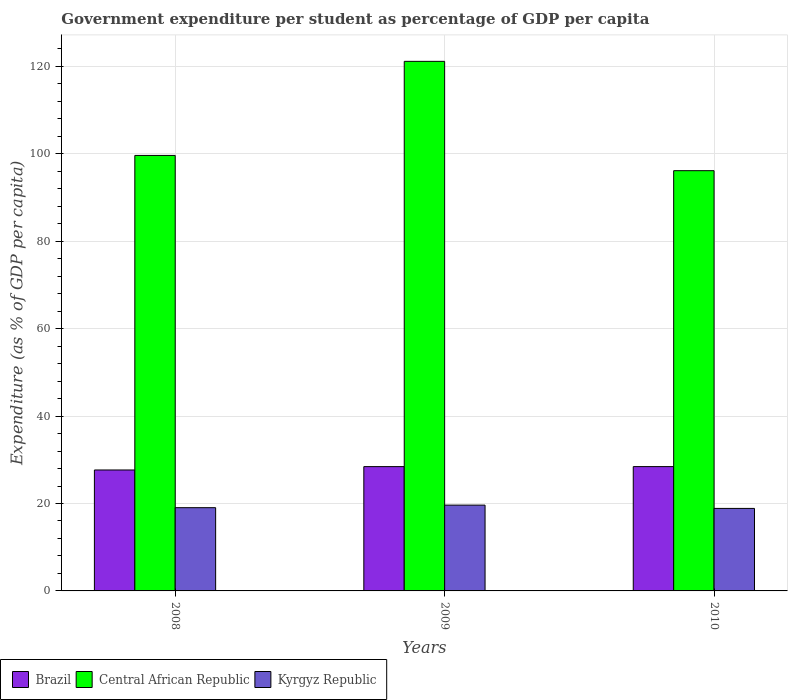How many different coloured bars are there?
Provide a short and direct response. 3. How many bars are there on the 1st tick from the right?
Your answer should be very brief. 3. What is the label of the 2nd group of bars from the left?
Give a very brief answer. 2009. In how many cases, is the number of bars for a given year not equal to the number of legend labels?
Your response must be concise. 0. What is the percentage of expenditure per student in Kyrgyz Republic in 2008?
Ensure brevity in your answer.  19.04. Across all years, what is the maximum percentage of expenditure per student in Central African Republic?
Provide a short and direct response. 121.16. Across all years, what is the minimum percentage of expenditure per student in Kyrgyz Republic?
Provide a short and direct response. 18.88. In which year was the percentage of expenditure per student in Brazil minimum?
Make the answer very short. 2008. What is the total percentage of expenditure per student in Kyrgyz Republic in the graph?
Ensure brevity in your answer.  57.55. What is the difference between the percentage of expenditure per student in Central African Republic in 2008 and that in 2010?
Keep it short and to the point. 3.49. What is the difference between the percentage of expenditure per student in Kyrgyz Republic in 2008 and the percentage of expenditure per student in Brazil in 2009?
Your answer should be compact. -9.4. What is the average percentage of expenditure per student in Central African Republic per year?
Make the answer very short. 105.64. In the year 2010, what is the difference between the percentage of expenditure per student in Kyrgyz Republic and percentage of expenditure per student in Central African Republic?
Provide a succinct answer. -77.27. What is the ratio of the percentage of expenditure per student in Brazil in 2009 to that in 2010?
Ensure brevity in your answer.  1. What is the difference between the highest and the second highest percentage of expenditure per student in Kyrgyz Republic?
Your answer should be very brief. 0.59. What is the difference between the highest and the lowest percentage of expenditure per student in Kyrgyz Republic?
Provide a succinct answer. 0.75. In how many years, is the percentage of expenditure per student in Central African Republic greater than the average percentage of expenditure per student in Central African Republic taken over all years?
Offer a very short reply. 1. What does the 3rd bar from the left in 2008 represents?
Make the answer very short. Kyrgyz Republic. What does the 2nd bar from the right in 2010 represents?
Ensure brevity in your answer.  Central African Republic. How many bars are there?
Provide a short and direct response. 9. How many years are there in the graph?
Offer a terse response. 3. Does the graph contain any zero values?
Ensure brevity in your answer.  No. How many legend labels are there?
Provide a succinct answer. 3. How are the legend labels stacked?
Offer a terse response. Horizontal. What is the title of the graph?
Your answer should be very brief. Government expenditure per student as percentage of GDP per capita. What is the label or title of the X-axis?
Your answer should be compact. Years. What is the label or title of the Y-axis?
Your answer should be very brief. Expenditure (as % of GDP per capita). What is the Expenditure (as % of GDP per capita) of Brazil in 2008?
Offer a terse response. 27.67. What is the Expenditure (as % of GDP per capita) in Central African Republic in 2008?
Offer a very short reply. 99.63. What is the Expenditure (as % of GDP per capita) of Kyrgyz Republic in 2008?
Offer a terse response. 19.04. What is the Expenditure (as % of GDP per capita) in Brazil in 2009?
Your answer should be very brief. 28.44. What is the Expenditure (as % of GDP per capita) of Central African Republic in 2009?
Provide a short and direct response. 121.16. What is the Expenditure (as % of GDP per capita) of Kyrgyz Republic in 2009?
Ensure brevity in your answer.  19.63. What is the Expenditure (as % of GDP per capita) in Brazil in 2010?
Offer a terse response. 28.44. What is the Expenditure (as % of GDP per capita) in Central African Republic in 2010?
Provide a short and direct response. 96.14. What is the Expenditure (as % of GDP per capita) in Kyrgyz Republic in 2010?
Make the answer very short. 18.88. Across all years, what is the maximum Expenditure (as % of GDP per capita) in Brazil?
Offer a very short reply. 28.44. Across all years, what is the maximum Expenditure (as % of GDP per capita) of Central African Republic?
Your answer should be very brief. 121.16. Across all years, what is the maximum Expenditure (as % of GDP per capita) in Kyrgyz Republic?
Offer a very short reply. 19.63. Across all years, what is the minimum Expenditure (as % of GDP per capita) in Brazil?
Offer a terse response. 27.67. Across all years, what is the minimum Expenditure (as % of GDP per capita) of Central African Republic?
Provide a short and direct response. 96.14. Across all years, what is the minimum Expenditure (as % of GDP per capita) in Kyrgyz Republic?
Keep it short and to the point. 18.88. What is the total Expenditure (as % of GDP per capita) in Brazil in the graph?
Provide a succinct answer. 84.55. What is the total Expenditure (as % of GDP per capita) of Central African Republic in the graph?
Your answer should be compact. 316.93. What is the total Expenditure (as % of GDP per capita) in Kyrgyz Republic in the graph?
Make the answer very short. 57.55. What is the difference between the Expenditure (as % of GDP per capita) of Brazil in 2008 and that in 2009?
Make the answer very short. -0.77. What is the difference between the Expenditure (as % of GDP per capita) of Central African Republic in 2008 and that in 2009?
Your answer should be compact. -21.52. What is the difference between the Expenditure (as % of GDP per capita) in Kyrgyz Republic in 2008 and that in 2009?
Provide a short and direct response. -0.59. What is the difference between the Expenditure (as % of GDP per capita) of Brazil in 2008 and that in 2010?
Offer a terse response. -0.77. What is the difference between the Expenditure (as % of GDP per capita) in Central African Republic in 2008 and that in 2010?
Keep it short and to the point. 3.49. What is the difference between the Expenditure (as % of GDP per capita) of Kyrgyz Republic in 2008 and that in 2010?
Make the answer very short. 0.17. What is the difference between the Expenditure (as % of GDP per capita) of Brazil in 2009 and that in 2010?
Provide a short and direct response. -0. What is the difference between the Expenditure (as % of GDP per capita) of Central African Republic in 2009 and that in 2010?
Offer a very short reply. 25.01. What is the difference between the Expenditure (as % of GDP per capita) in Kyrgyz Republic in 2009 and that in 2010?
Make the answer very short. 0.75. What is the difference between the Expenditure (as % of GDP per capita) of Brazil in 2008 and the Expenditure (as % of GDP per capita) of Central African Republic in 2009?
Provide a succinct answer. -93.49. What is the difference between the Expenditure (as % of GDP per capita) in Brazil in 2008 and the Expenditure (as % of GDP per capita) in Kyrgyz Republic in 2009?
Make the answer very short. 8.04. What is the difference between the Expenditure (as % of GDP per capita) in Central African Republic in 2008 and the Expenditure (as % of GDP per capita) in Kyrgyz Republic in 2009?
Give a very brief answer. 80. What is the difference between the Expenditure (as % of GDP per capita) in Brazil in 2008 and the Expenditure (as % of GDP per capita) in Central African Republic in 2010?
Your answer should be very brief. -68.47. What is the difference between the Expenditure (as % of GDP per capita) of Brazil in 2008 and the Expenditure (as % of GDP per capita) of Kyrgyz Republic in 2010?
Provide a succinct answer. 8.79. What is the difference between the Expenditure (as % of GDP per capita) in Central African Republic in 2008 and the Expenditure (as % of GDP per capita) in Kyrgyz Republic in 2010?
Offer a very short reply. 80.76. What is the difference between the Expenditure (as % of GDP per capita) in Brazil in 2009 and the Expenditure (as % of GDP per capita) in Central African Republic in 2010?
Keep it short and to the point. -67.7. What is the difference between the Expenditure (as % of GDP per capita) of Brazil in 2009 and the Expenditure (as % of GDP per capita) of Kyrgyz Republic in 2010?
Ensure brevity in your answer.  9.56. What is the difference between the Expenditure (as % of GDP per capita) of Central African Republic in 2009 and the Expenditure (as % of GDP per capita) of Kyrgyz Republic in 2010?
Ensure brevity in your answer.  102.28. What is the average Expenditure (as % of GDP per capita) in Brazil per year?
Offer a terse response. 28.18. What is the average Expenditure (as % of GDP per capita) in Central African Republic per year?
Give a very brief answer. 105.64. What is the average Expenditure (as % of GDP per capita) of Kyrgyz Republic per year?
Your response must be concise. 19.18. In the year 2008, what is the difference between the Expenditure (as % of GDP per capita) in Brazil and Expenditure (as % of GDP per capita) in Central African Republic?
Your answer should be compact. -71.96. In the year 2008, what is the difference between the Expenditure (as % of GDP per capita) in Brazil and Expenditure (as % of GDP per capita) in Kyrgyz Republic?
Offer a very short reply. 8.63. In the year 2008, what is the difference between the Expenditure (as % of GDP per capita) of Central African Republic and Expenditure (as % of GDP per capita) of Kyrgyz Republic?
Your response must be concise. 80.59. In the year 2009, what is the difference between the Expenditure (as % of GDP per capita) of Brazil and Expenditure (as % of GDP per capita) of Central African Republic?
Provide a succinct answer. -92.72. In the year 2009, what is the difference between the Expenditure (as % of GDP per capita) in Brazil and Expenditure (as % of GDP per capita) in Kyrgyz Republic?
Provide a succinct answer. 8.81. In the year 2009, what is the difference between the Expenditure (as % of GDP per capita) of Central African Republic and Expenditure (as % of GDP per capita) of Kyrgyz Republic?
Ensure brevity in your answer.  101.53. In the year 2010, what is the difference between the Expenditure (as % of GDP per capita) in Brazil and Expenditure (as % of GDP per capita) in Central African Republic?
Ensure brevity in your answer.  -67.7. In the year 2010, what is the difference between the Expenditure (as % of GDP per capita) of Brazil and Expenditure (as % of GDP per capita) of Kyrgyz Republic?
Give a very brief answer. 9.57. In the year 2010, what is the difference between the Expenditure (as % of GDP per capita) of Central African Republic and Expenditure (as % of GDP per capita) of Kyrgyz Republic?
Offer a very short reply. 77.27. What is the ratio of the Expenditure (as % of GDP per capita) of Central African Republic in 2008 to that in 2009?
Keep it short and to the point. 0.82. What is the ratio of the Expenditure (as % of GDP per capita) in Brazil in 2008 to that in 2010?
Your answer should be very brief. 0.97. What is the ratio of the Expenditure (as % of GDP per capita) of Central African Republic in 2008 to that in 2010?
Give a very brief answer. 1.04. What is the ratio of the Expenditure (as % of GDP per capita) in Kyrgyz Republic in 2008 to that in 2010?
Provide a succinct answer. 1.01. What is the ratio of the Expenditure (as % of GDP per capita) of Central African Republic in 2009 to that in 2010?
Your answer should be compact. 1.26. What is the difference between the highest and the second highest Expenditure (as % of GDP per capita) in Brazil?
Your answer should be compact. 0. What is the difference between the highest and the second highest Expenditure (as % of GDP per capita) of Central African Republic?
Ensure brevity in your answer.  21.52. What is the difference between the highest and the second highest Expenditure (as % of GDP per capita) in Kyrgyz Republic?
Give a very brief answer. 0.59. What is the difference between the highest and the lowest Expenditure (as % of GDP per capita) in Brazil?
Offer a very short reply. 0.77. What is the difference between the highest and the lowest Expenditure (as % of GDP per capita) in Central African Republic?
Provide a succinct answer. 25.01. What is the difference between the highest and the lowest Expenditure (as % of GDP per capita) in Kyrgyz Republic?
Your response must be concise. 0.75. 